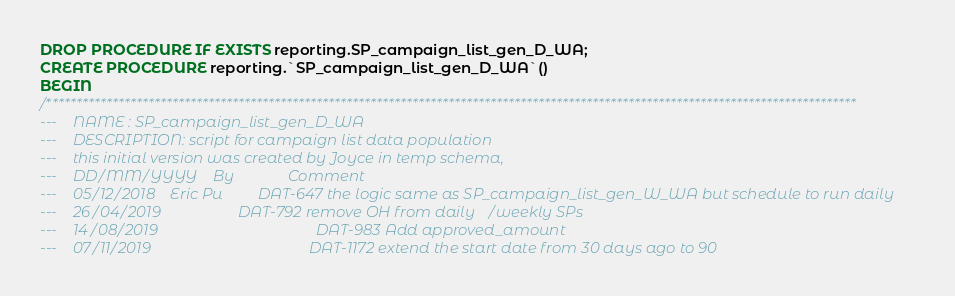Convert code to text. <code><loc_0><loc_0><loc_500><loc_500><_SQL_>DROP PROCEDURE IF EXISTS reporting.SP_campaign_list_gen_D_WA;
CREATE PROCEDURE reporting.`SP_campaign_list_gen_D_WA`()
BEGIN
/***************************************************************************************************************************************
---    NAME : SP_campaign_list_gen_D_WA
---    DESCRIPTION: script for campaign list data population
---    this initial version was created by Joyce in temp schema, 
---    DD/MM/YYYY    By              Comment
---    05/12/2018    Eric Pu         DAT-647 the logic same as SP_campaign_list_gen_W_WA but schedule to run daily
---    26/04/2019                    DAT-792 remove OH from daily/weekly SPs
---    14/08/2019										 DAT-983 Add approved_amount
---    07/11/2019										 DAT-1172 extend the start date from 30 days ago to 90</code> 